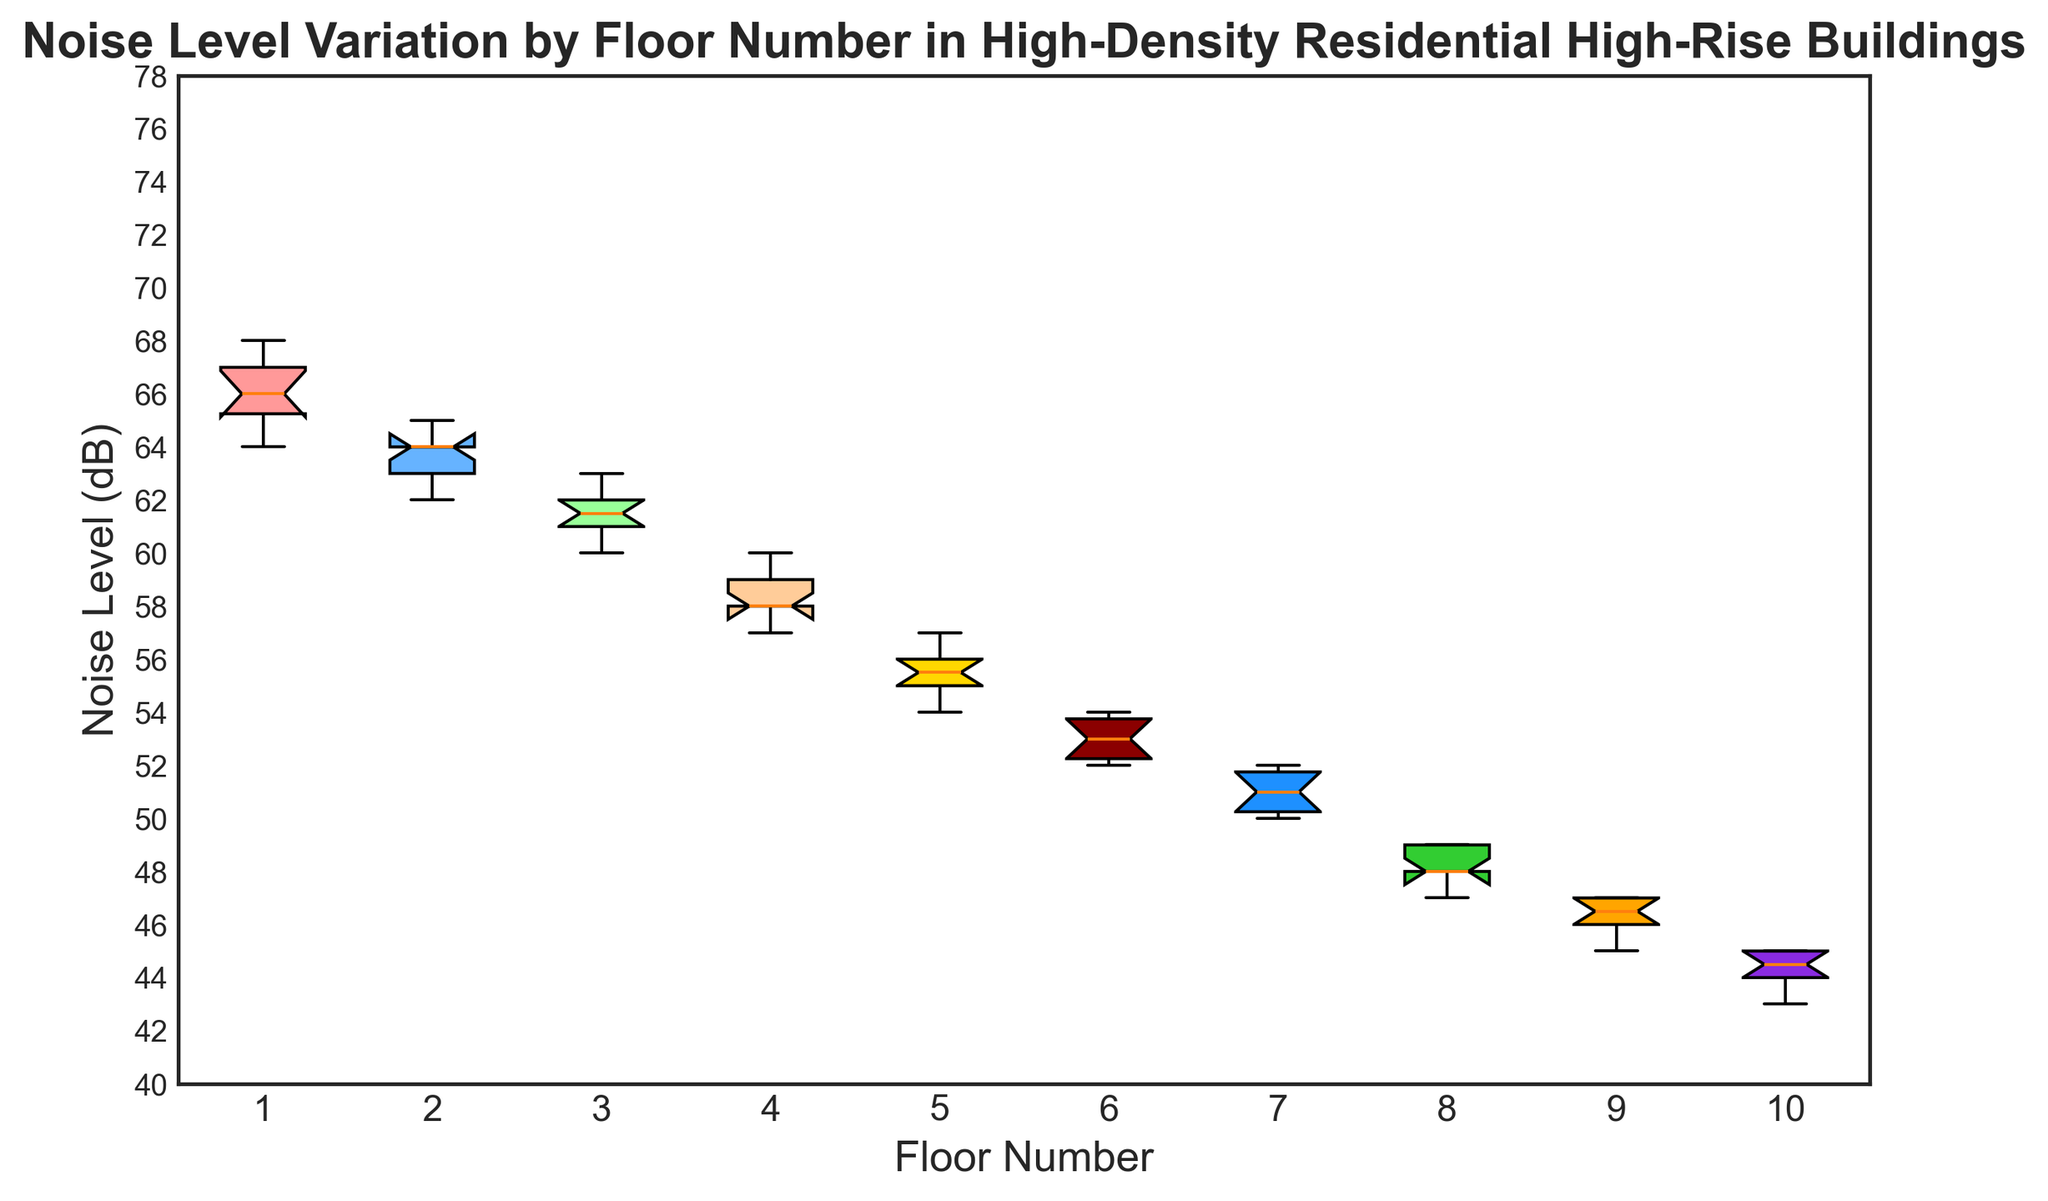what is the median noise level on the 5th floor? To find the median noise level on the 5th floor, observe the 5th box from the left side of the plot. The median is represented by the line in the middle of the box.
Answer: 55 which floor has the highest median noise level? Look at the medians (the lines inside the boxes) of all the floors and find the highest one. The first floor has the highest median noise level.
Answer: 1st floor are the noise levels more variable on the 1st floor or the 10th floor? The variability can be observed by the height of the boxes (interquartile range). Compare the height of the boxes for the 1st and 10th floors. The 1st floor’s box is taller, indicating more variability.
Answer: 1st floor do higher floors generally have lower noise levels? Observe the trend of the medians from the 1st floor to the 10th floor. Check if there is a decreasing pattern as the floor number increases. The noise levels generally decrease as floors go higher.
Answer: Yes between the 3rd and the 6th floors, which floors have outliers? Outliers are marked with red dots outside the whiskers of the boxes. Identify the floors between the 3rd and the 6th that have red dots. None of the floors between the 3rd and the 6th have outliers.
Answer: None what is the interquartile range (IQR) of noise levels on the 2nd floor? The IQR is the difference between the top (75th percentile) and bottom (25th percentile) edges of the box. For the 2nd floor, observe these values and calculate the difference.
Answer: 1 how does the mean noise level on the 7th floor compare to the 4th floor? While not directly shown on the plot, the mean is typically around the median if the distribution is not highly skewed. Compare the median values and describe the relative difference. The median on the 7th floor is higher than the 4th floor, indicating a higher mean likely.
Answer: Higher on the 7th floor which floor appears to be the quietest? The quietest floor can be determined by finding the floor with the lowest median noise level. Check the box plots for all floors and find the lowest median. The 10th floor has the lowest median noise level.
Answer: 10th floor which floor shows the most consistent noise levels? Consistency in noise levels is indicated by the smallest interquartile range (IQR). Find the floor with the smallest box height. The 5th floor shows the most consistent noise levels.
Answer: 5th floor do any floors have identical median noise levels, and if so, which ones? Check all the median lines (inside the boxes) and identify if any are at the same vertical position. The 9th and 10th floors have the same median noise level.
Answer: 9th and 10th 